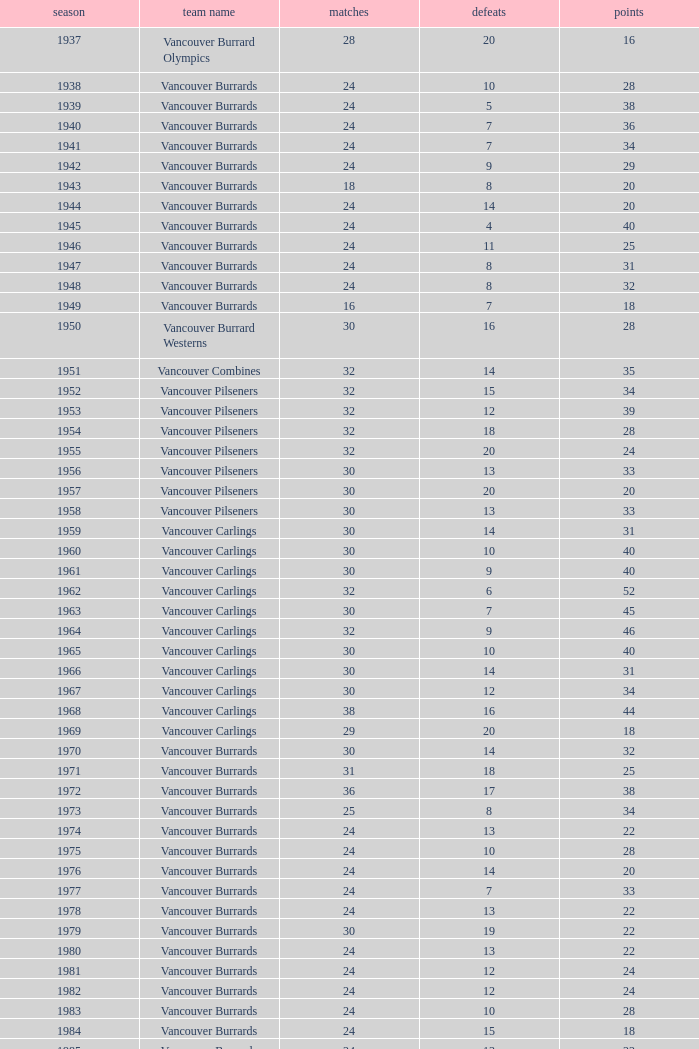What's the sum of points for the 1963 season when there are more than 30 games? None. 